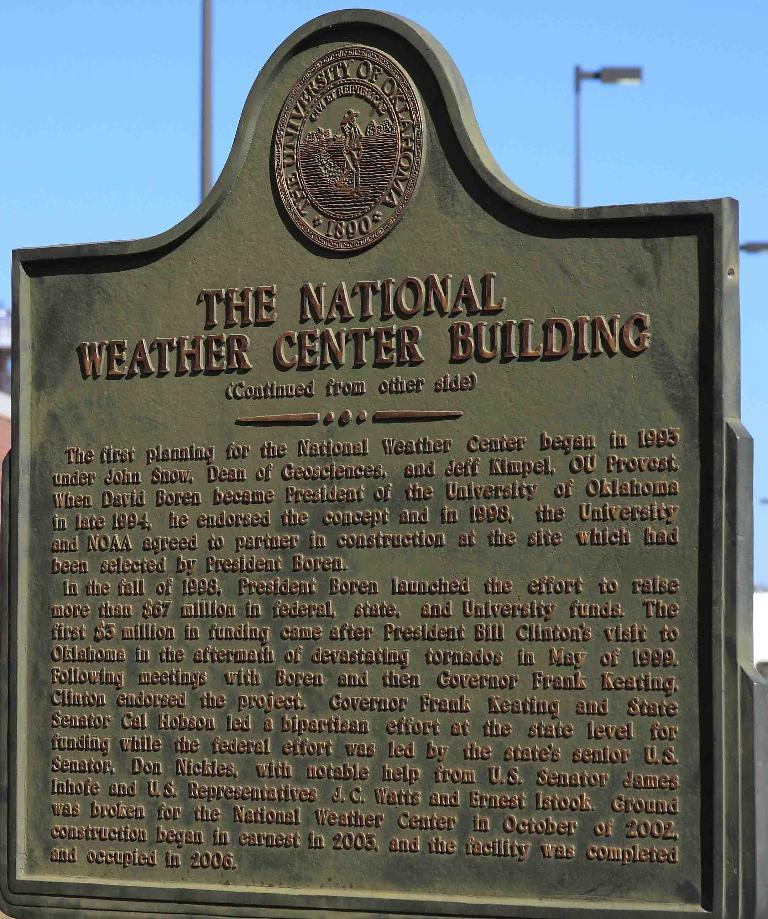<image>
Provide a brief description of the given image. A sign sponsored by the University of Oklahoma that tells about The National Weather Center Building 